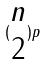<formula> <loc_0><loc_0><loc_500><loc_500>( \begin{matrix} n \\ 2 \end{matrix} ) p</formula> 